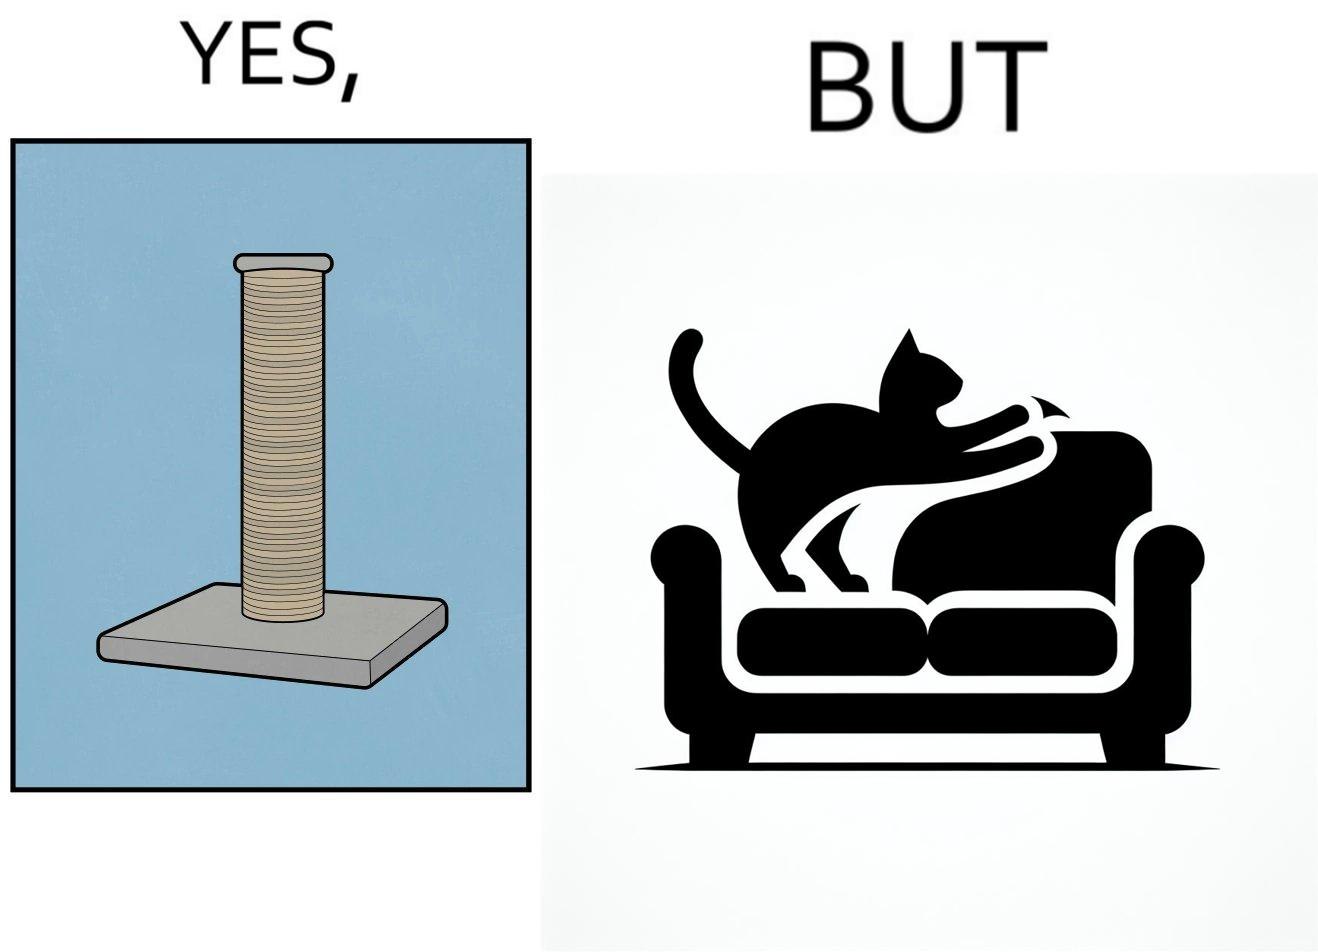Is this a satirical image? Yes, this image is satirical. 